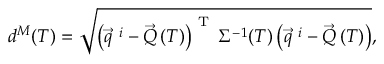Convert formula to latex. <formula><loc_0><loc_0><loc_500><loc_500>d ^ { M } ( T ) = \sqrt { \left ( \vec { q } ^ { \ i } - \vec { Q } \left ( T \right ) \right ) ^ { T } \Sigma ^ { - 1 } ( T ) \left ( \vec { q } ^ { \ i } - \vec { Q } \left ( T \right ) \right ) } ,</formula> 